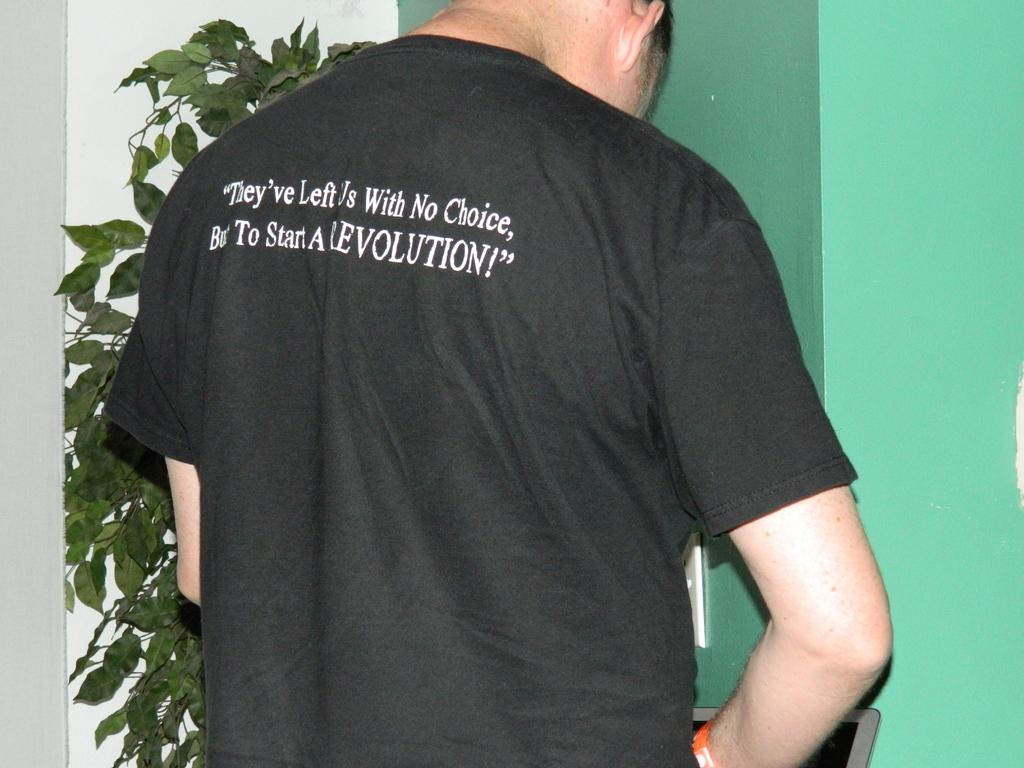<image>
Present a compact description of the photo's key features. A man is wearing a black shirt with the word choice on the back. 